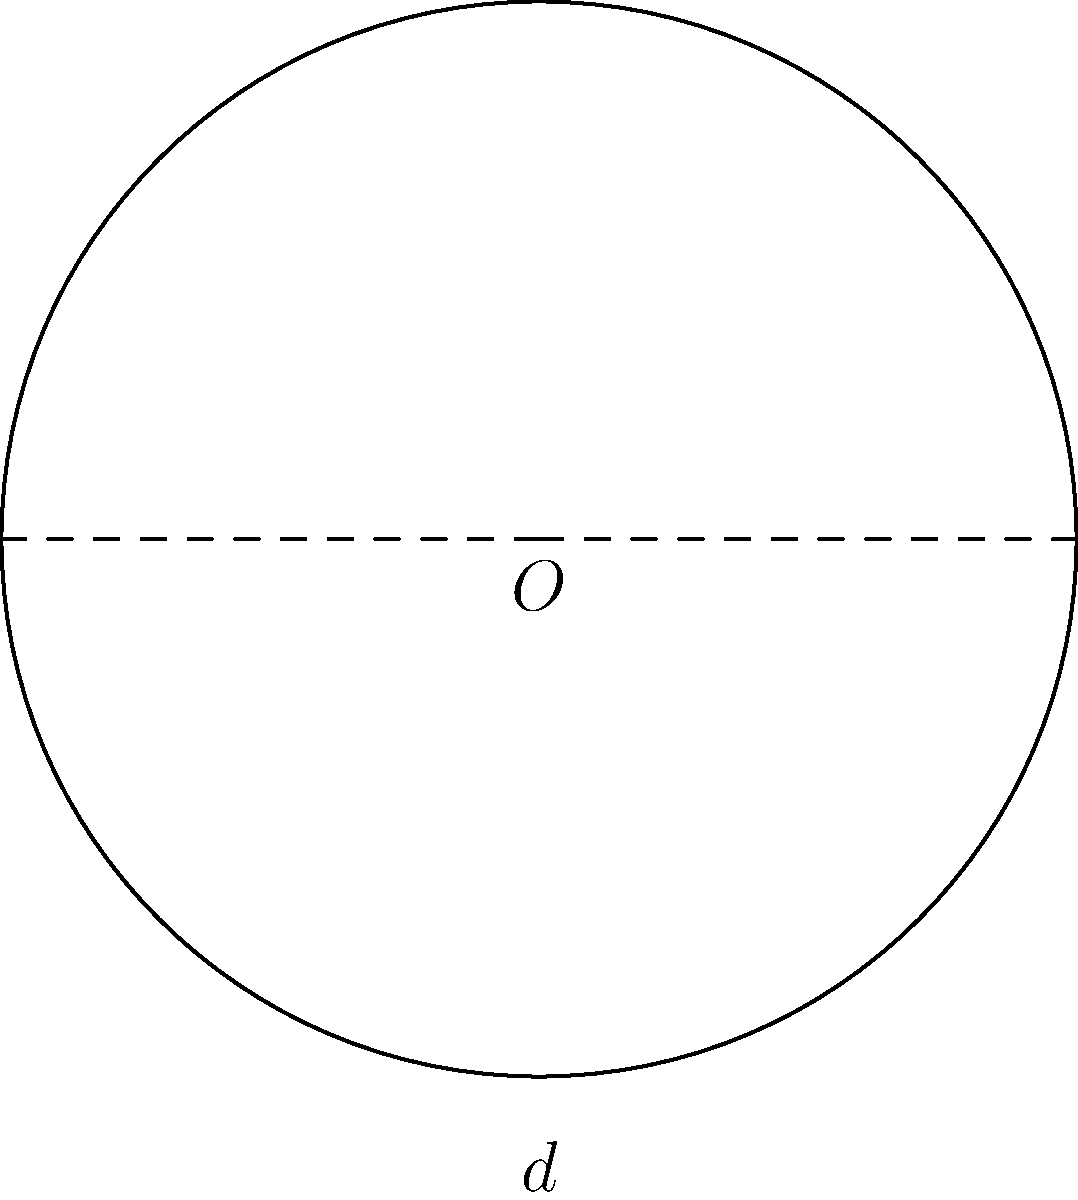As a supplier of high-quality raw materials for motorcycle parts, you're tasked with calculating the circumference of a circular gear. If the diameter of the gear is 60 mm, what is its circumference? Use $\pi \approx 3.14159$ for your calculation. To calculate the circumference of a circular gear, we can use the formula:

$$C = \pi d$$

Where:
$C$ = circumference
$\pi$ = pi (approximately 3.14159)
$d$ = diameter

Given:
$d = 60$ mm
$\pi \approx 3.14159$

Step 1: Substitute the values into the formula:
$$C = \pi d = 3.14159 \times 60$$

Step 2: Perform the multiplication:
$$C = 188.4954 \text{ mm}$$

Step 3: Round to two decimal places for practical purposes:
$$C \approx 188.50 \text{ mm}$$

Therefore, the circumference of the circular gear is approximately 188.50 mm.
Answer: 188.50 mm 